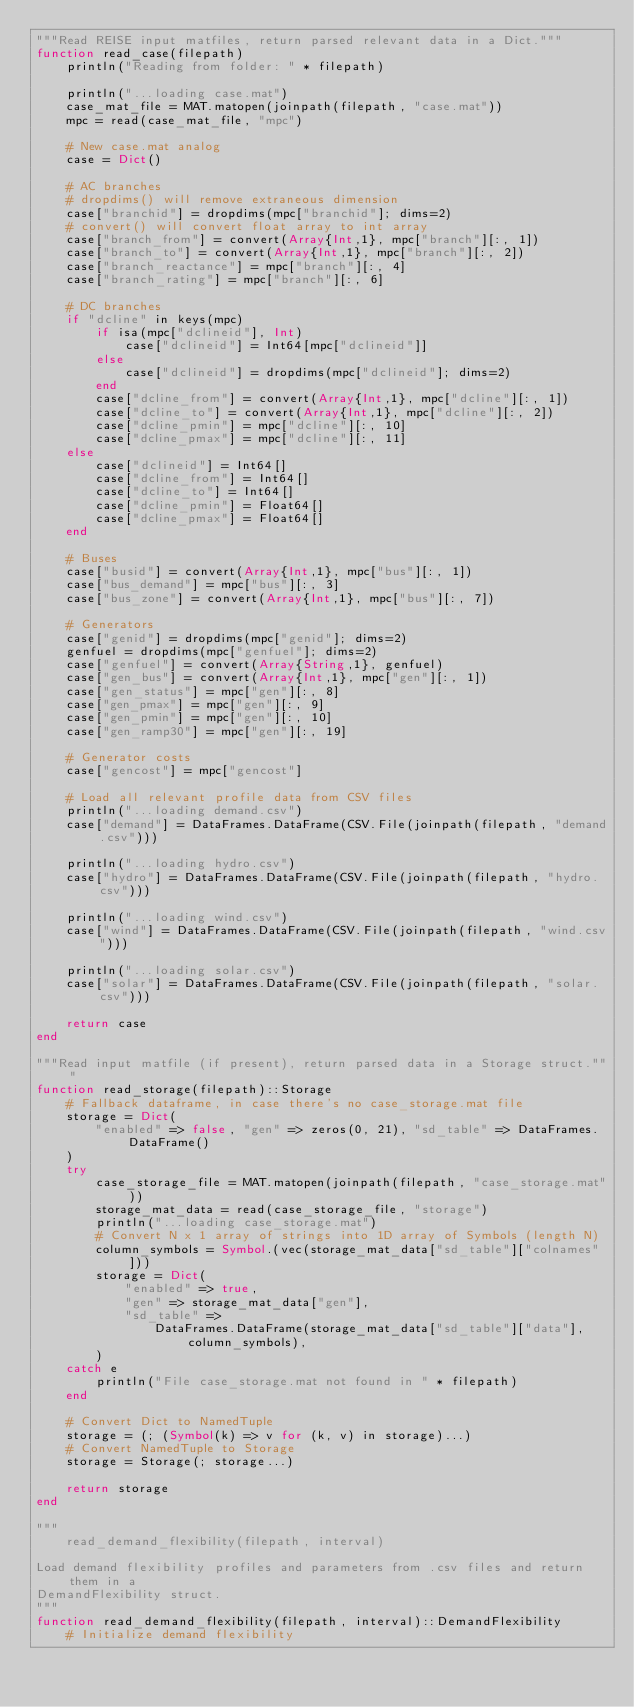<code> <loc_0><loc_0><loc_500><loc_500><_Julia_>"""Read REISE input matfiles, return parsed relevant data in a Dict."""
function read_case(filepath)
    println("Reading from folder: " * filepath)

    println("...loading case.mat")
    case_mat_file = MAT.matopen(joinpath(filepath, "case.mat"))
    mpc = read(case_mat_file, "mpc")

    # New case.mat analog
    case = Dict()

    # AC branches
    # dropdims() will remove extraneous dimension
    case["branchid"] = dropdims(mpc["branchid"]; dims=2)
    # convert() will convert float array to int array
    case["branch_from"] = convert(Array{Int,1}, mpc["branch"][:, 1])
    case["branch_to"] = convert(Array{Int,1}, mpc["branch"][:, 2])
    case["branch_reactance"] = mpc["branch"][:, 4]
    case["branch_rating"] = mpc["branch"][:, 6]

    # DC branches
    if "dcline" in keys(mpc)
        if isa(mpc["dclineid"], Int)
            case["dclineid"] = Int64[mpc["dclineid"]]
        else
            case["dclineid"] = dropdims(mpc["dclineid"]; dims=2)
        end
        case["dcline_from"] = convert(Array{Int,1}, mpc["dcline"][:, 1])
        case["dcline_to"] = convert(Array{Int,1}, mpc["dcline"][:, 2])
        case["dcline_pmin"] = mpc["dcline"][:, 10]
        case["dcline_pmax"] = mpc["dcline"][:, 11]
    else
        case["dclineid"] = Int64[]
        case["dcline_from"] = Int64[]
        case["dcline_to"] = Int64[]
        case["dcline_pmin"] = Float64[]
        case["dcline_pmax"] = Float64[]
    end

    # Buses
    case["busid"] = convert(Array{Int,1}, mpc["bus"][:, 1])
    case["bus_demand"] = mpc["bus"][:, 3]
    case["bus_zone"] = convert(Array{Int,1}, mpc["bus"][:, 7])

    # Generators
    case["genid"] = dropdims(mpc["genid"]; dims=2)
    genfuel = dropdims(mpc["genfuel"]; dims=2)
    case["genfuel"] = convert(Array{String,1}, genfuel)
    case["gen_bus"] = convert(Array{Int,1}, mpc["gen"][:, 1])
    case["gen_status"] = mpc["gen"][:, 8]
    case["gen_pmax"] = mpc["gen"][:, 9]
    case["gen_pmin"] = mpc["gen"][:, 10]
    case["gen_ramp30"] = mpc["gen"][:, 19]

    # Generator costs
    case["gencost"] = mpc["gencost"]

    # Load all relevant profile data from CSV files
    println("...loading demand.csv")
    case["demand"] = DataFrames.DataFrame(CSV.File(joinpath(filepath, "demand.csv")))

    println("...loading hydro.csv")
    case["hydro"] = DataFrames.DataFrame(CSV.File(joinpath(filepath, "hydro.csv")))

    println("...loading wind.csv")
    case["wind"] = DataFrames.DataFrame(CSV.File(joinpath(filepath, "wind.csv")))

    println("...loading solar.csv")
    case["solar"] = DataFrames.DataFrame(CSV.File(joinpath(filepath, "solar.csv")))

    return case
end

"""Read input matfile (if present), return parsed data in a Storage struct."""
function read_storage(filepath)::Storage
    # Fallback dataframe, in case there's no case_storage.mat file
    storage = Dict(
        "enabled" => false, "gen" => zeros(0, 21), "sd_table" => DataFrames.DataFrame()
    )
    try
        case_storage_file = MAT.matopen(joinpath(filepath, "case_storage.mat"))
        storage_mat_data = read(case_storage_file, "storage")
        println("...loading case_storage.mat")
        # Convert N x 1 array of strings into 1D array of Symbols (length N)
        column_symbols = Symbol.(vec(storage_mat_data["sd_table"]["colnames"]))
        storage = Dict(
            "enabled" => true,
            "gen" => storage_mat_data["gen"],
            "sd_table" =>
                DataFrames.DataFrame(storage_mat_data["sd_table"]["data"], column_symbols),
        )
    catch e
        println("File case_storage.mat not found in " * filepath)
    end

    # Convert Dict to NamedTuple
    storage = (; (Symbol(k) => v for (k, v) in storage)...)
    # Convert NamedTuple to Storage
    storage = Storage(; storage...)

    return storage
end

"""
    read_demand_flexibility(filepath, interval)

Load demand flexibility profiles and parameters from .csv files and return them in a 
DemandFlexibility struct.
"""
function read_demand_flexibility(filepath, interval)::DemandFlexibility
    # Initialize demand flexibility</code> 